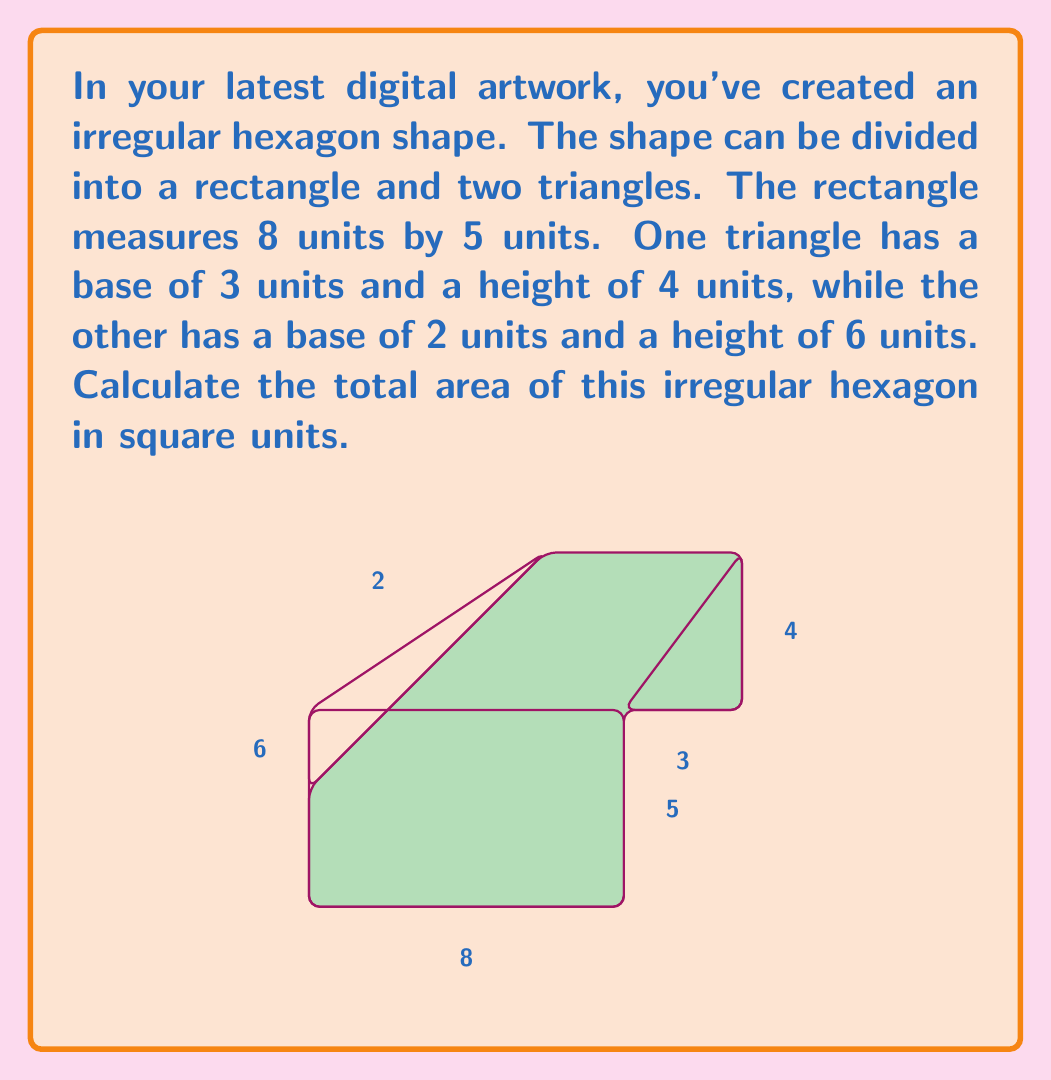Could you help me with this problem? To find the total area of the irregular hexagon, we need to calculate the areas of its component shapes and sum them up. Let's break it down step by step:

1. Area of the rectangle:
   $A_r = l \times w = 8 \times 5 = 40$ square units

2. Area of the first triangle (right side):
   $A_{t1} = \frac{1}{2} \times b \times h = \frac{1}{2} \times 3 \times 4 = 6$ square units

3. Area of the second triangle (left side):
   $A_{t2} = \frac{1}{2} \times b \times h = \frac{1}{2} \times 2 \times 6 = 6$ square units

4. Total area of the irregular hexagon:
   $$A_{total} = A_r + A_{t1} + A_{t2}$$
   $$A_{total} = 40 + 6 + 6 = 52$$ square units

Therefore, the total area of the irregular hexagon in your digital artwork is 52 square units.
Answer: 52 square units 